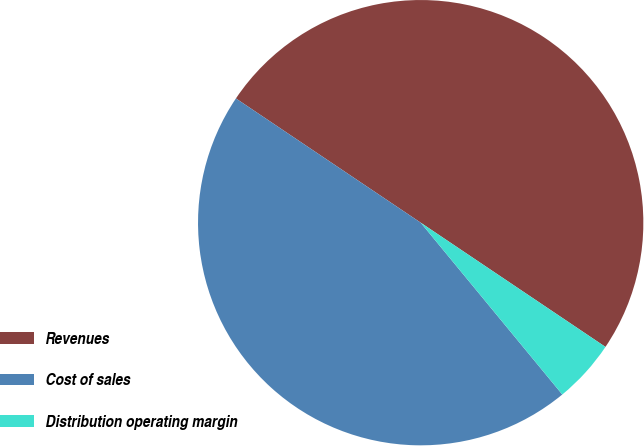<chart> <loc_0><loc_0><loc_500><loc_500><pie_chart><fcel>Revenues<fcel>Cost of sales<fcel>Distribution operating margin<nl><fcel>50.0%<fcel>45.39%<fcel>4.61%<nl></chart> 